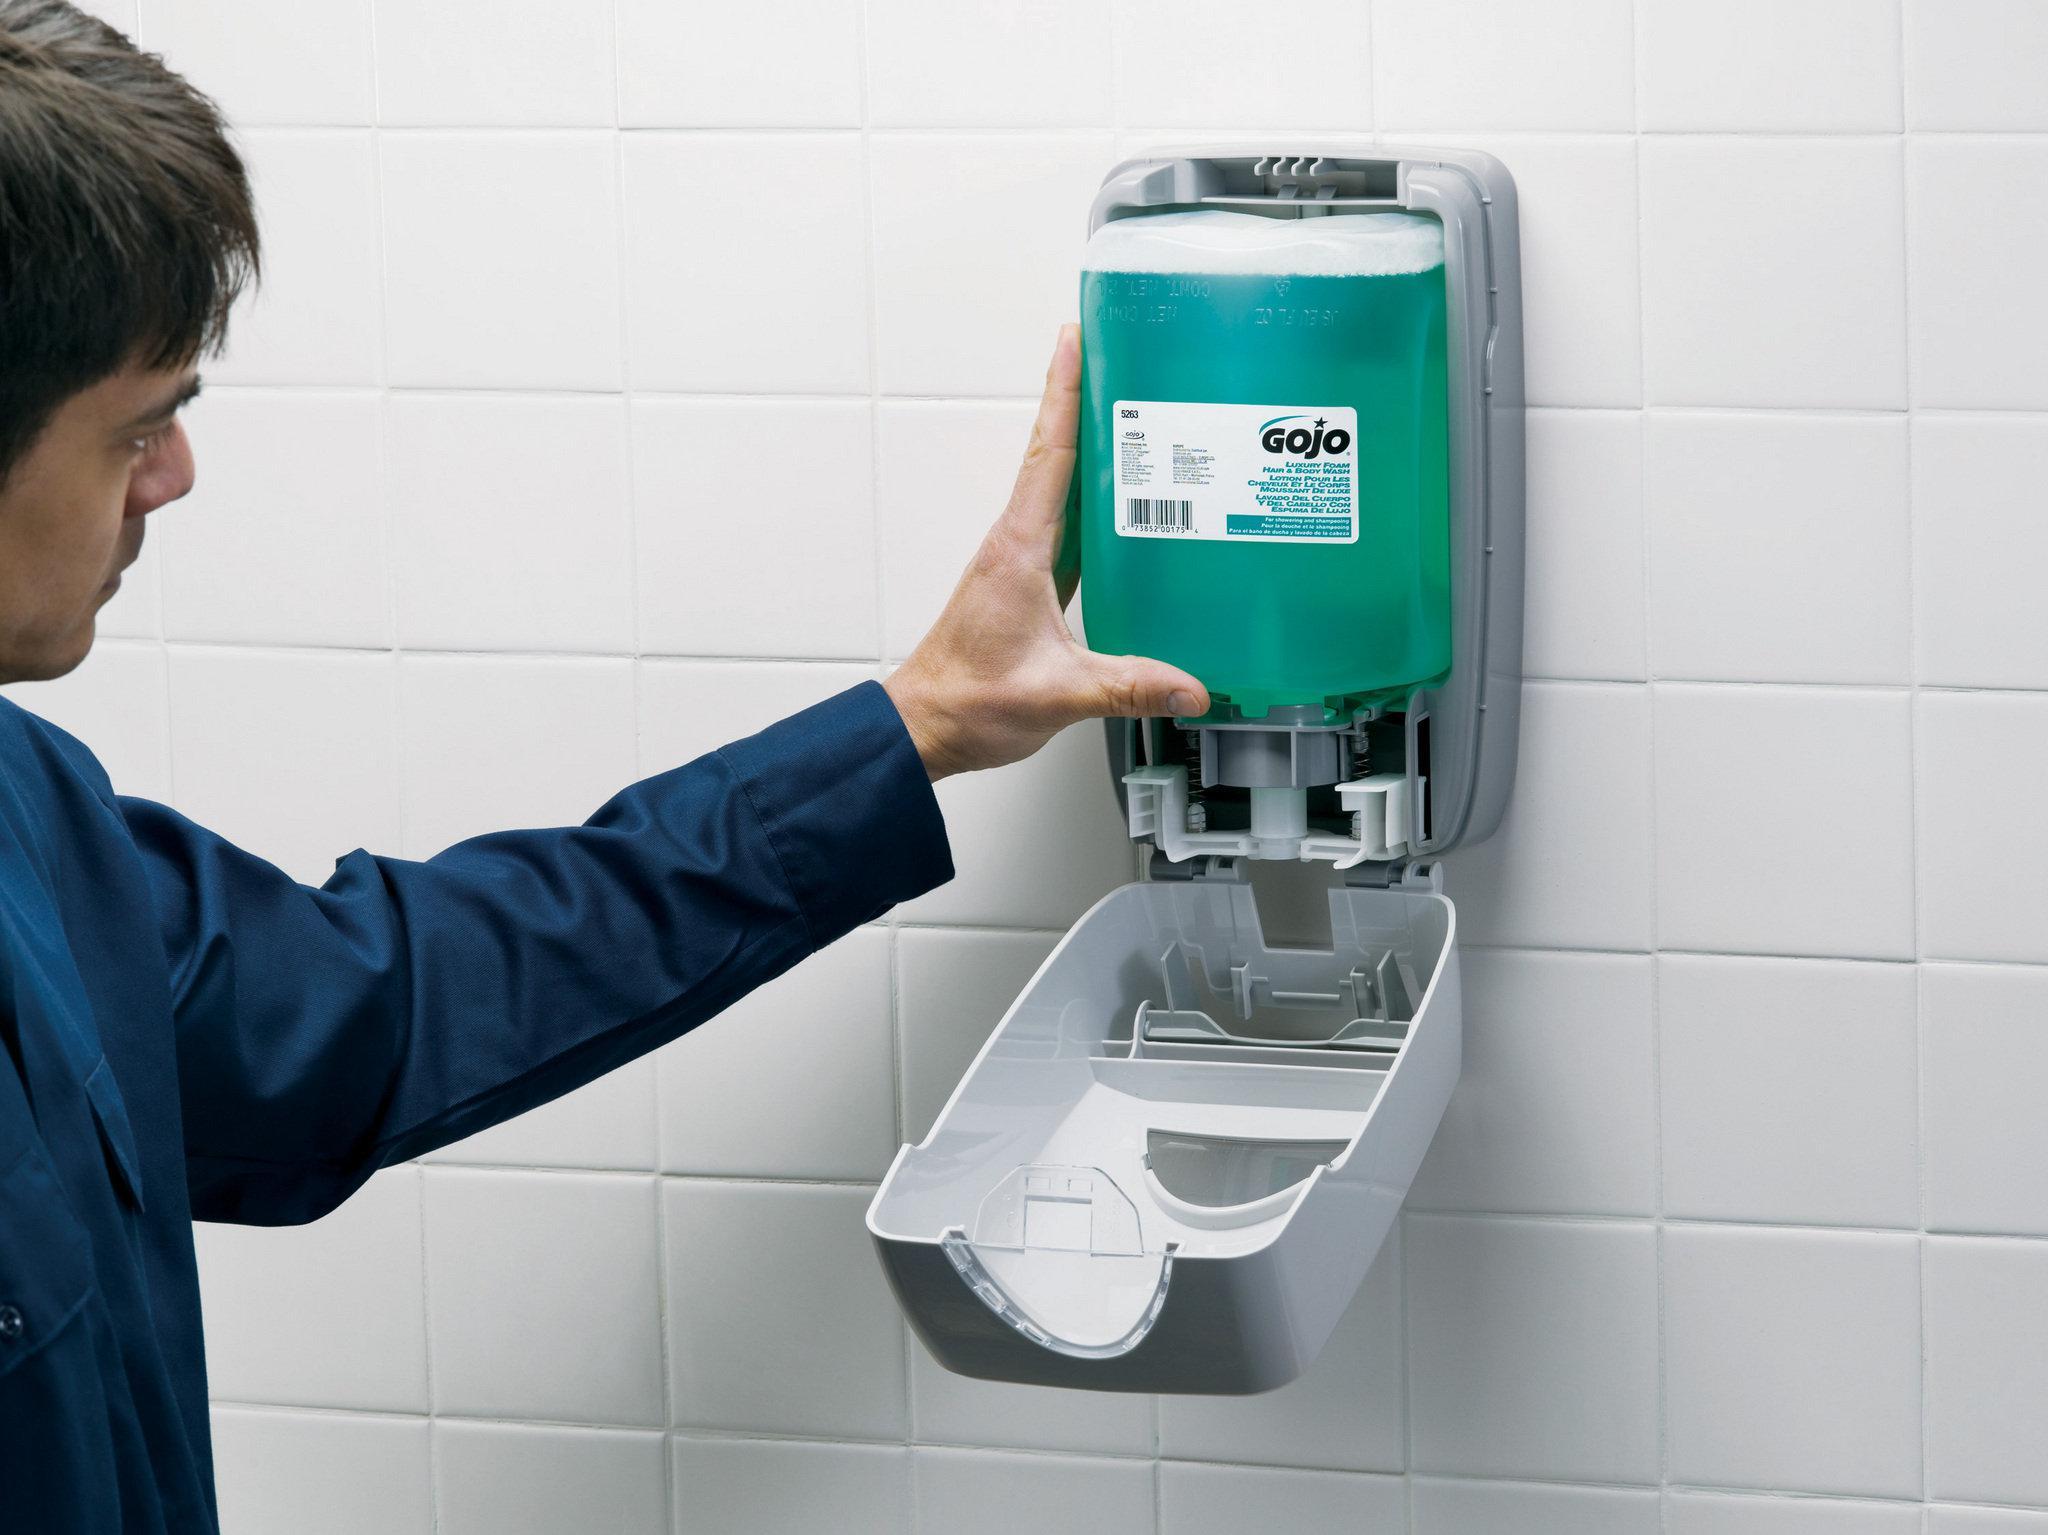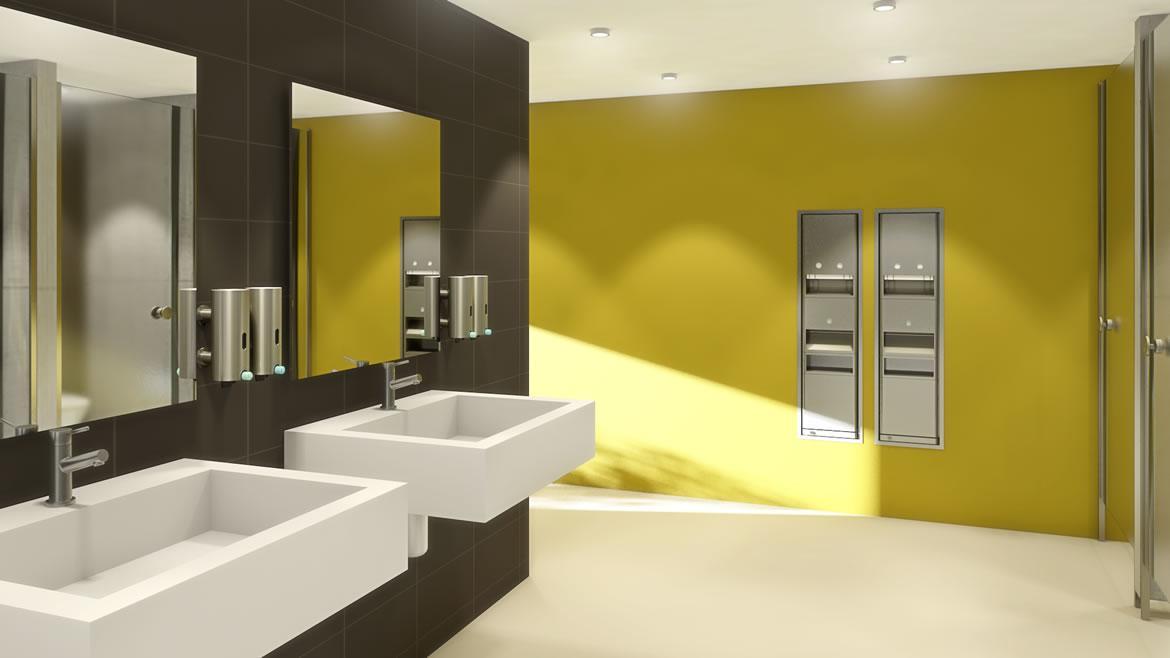The first image is the image on the left, the second image is the image on the right. For the images displayed, is the sentence "The right image contains at least two sinks." factually correct? Answer yes or no. Yes. The first image is the image on the left, the second image is the image on the right. Analyze the images presented: Is the assertion "In at least one image, a human hand is visible interacting with a soap dispenser" valid? Answer yes or no. Yes. 